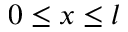Convert formula to latex. <formula><loc_0><loc_0><loc_500><loc_500>0 \leq x \leq l</formula> 